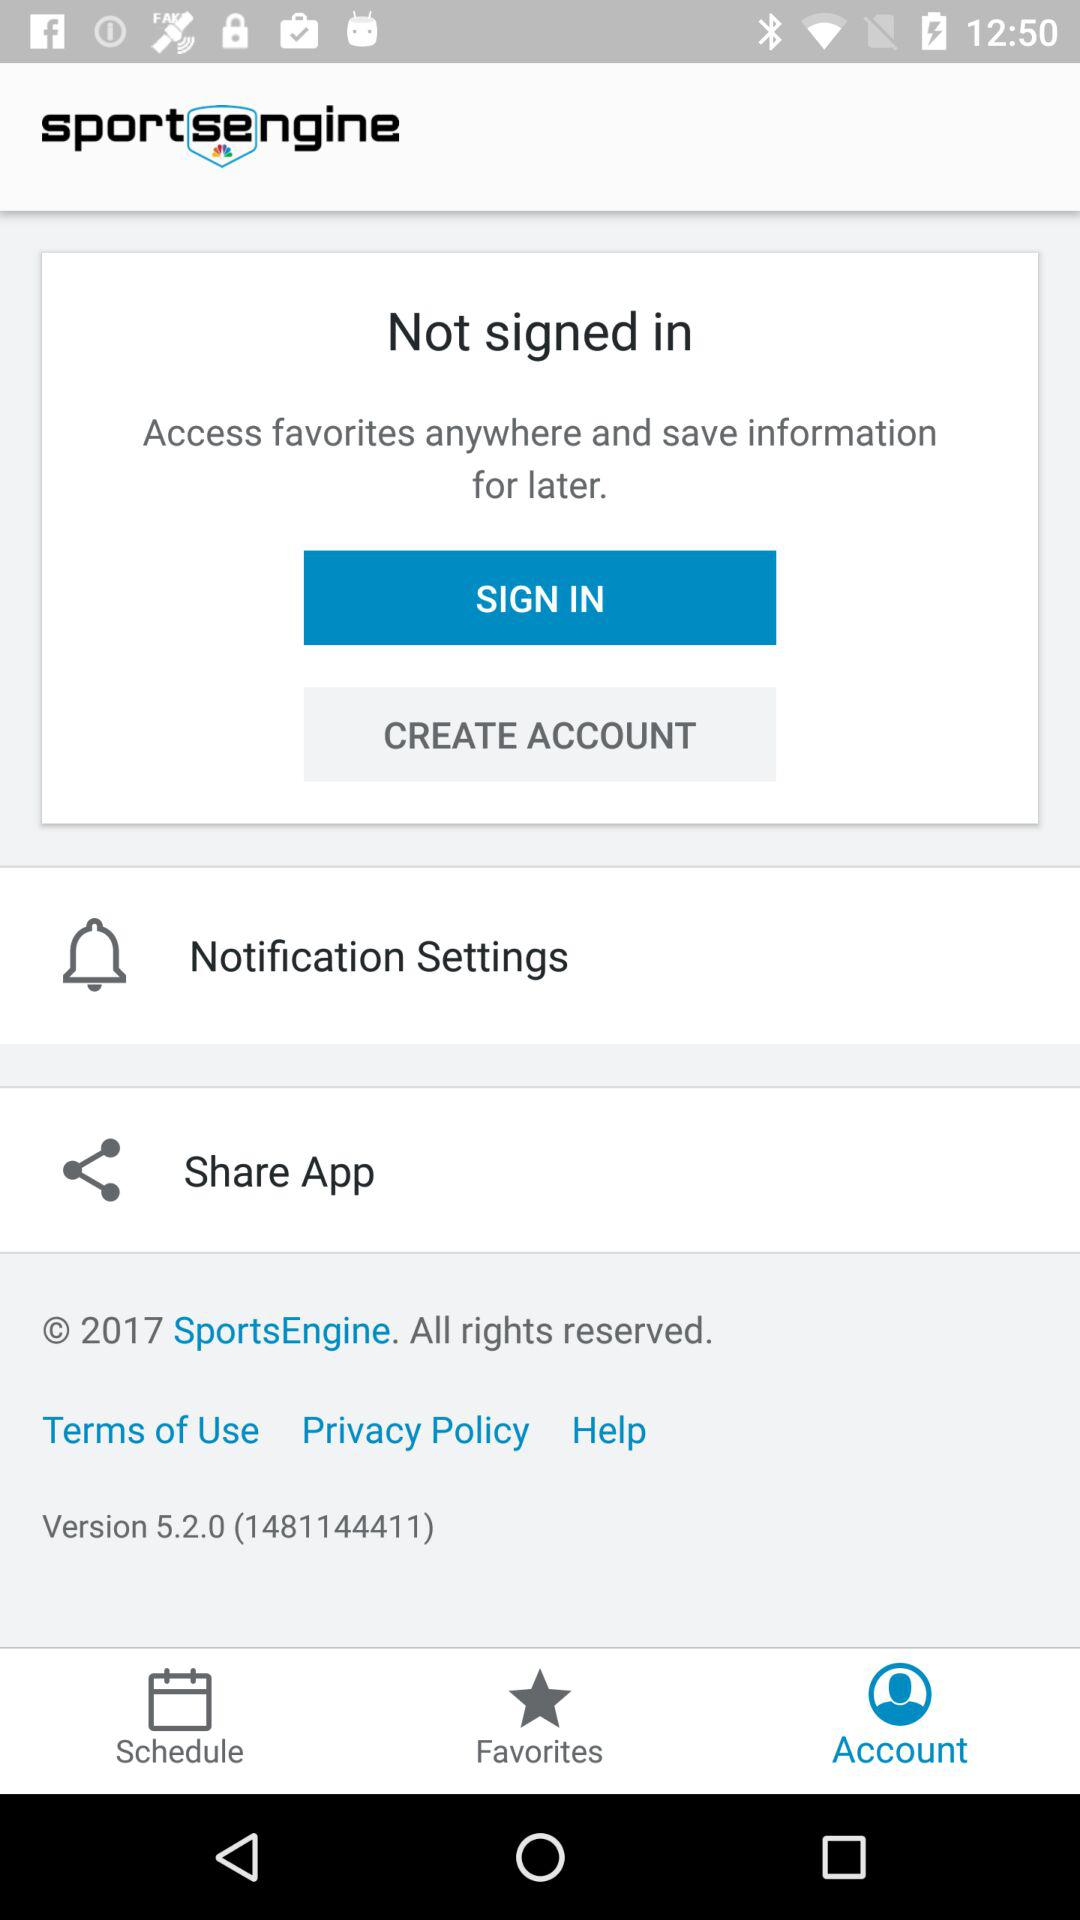What is the version of the application being used? The version of the application being used is 5.2.0 (1481144411). 